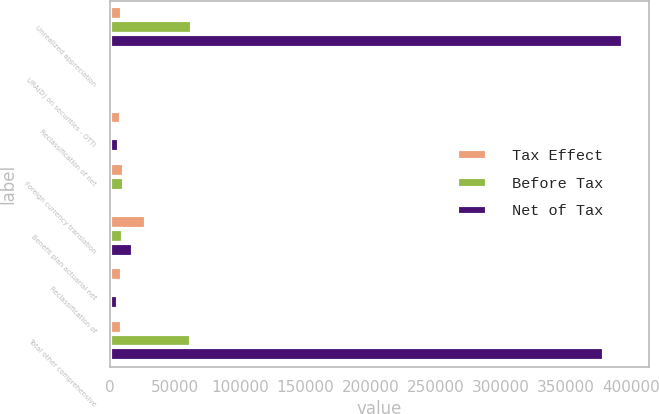Convert chart. <chart><loc_0><loc_0><loc_500><loc_500><stacked_bar_chart><ecel><fcel>Unrealized appreciation<fcel>URA(D) on securities - OTTI<fcel>Reclassification of net<fcel>Foreign currency translation<fcel>Benefit plan actuarial net<fcel>Reclassification of<fcel>Total other comprehensive<nl><fcel>Tax Effect<fcel>8889<fcel>1579<fcel>8388<fcel>10462<fcel>27442<fcel>8889<fcel>8889<nl><fcel>Before Tax<fcel>62834<fcel>140<fcel>1411<fcel>10300<fcel>9605<fcel>3111<fcel>61969<nl><fcel>Net of Tax<fcel>394358<fcel>1439<fcel>6977<fcel>162<fcel>17837<fcel>5778<fcel>379321<nl></chart> 